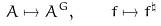<formula> <loc_0><loc_0><loc_500><loc_500>A \mapsto A ^ { G } , \quad f \mapsto f ^ { \natural }</formula> 